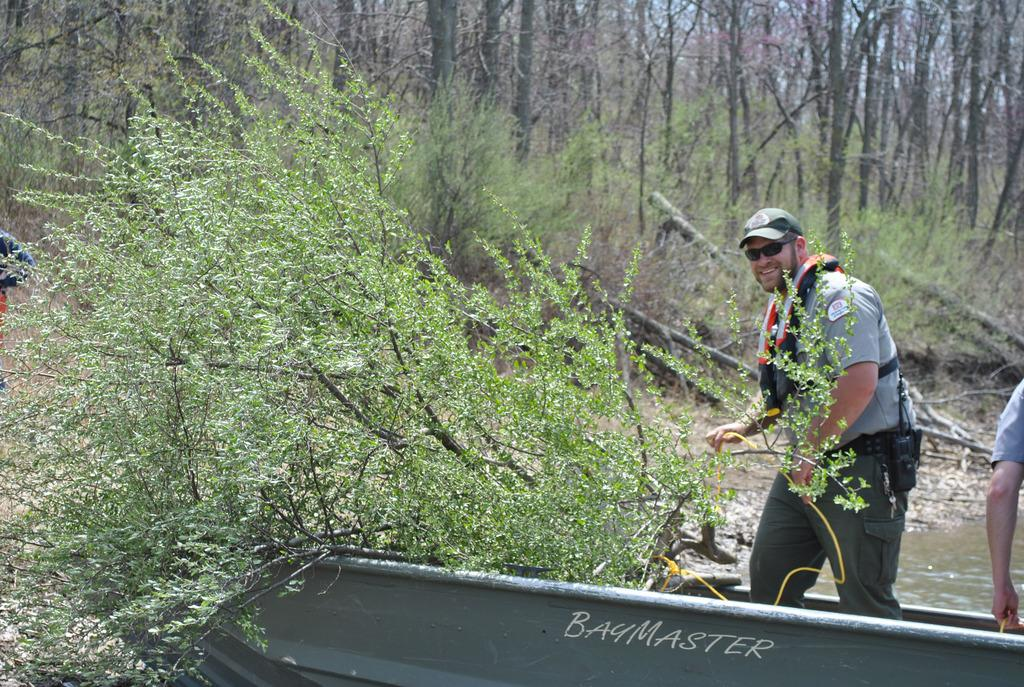<image>
Share a concise interpretation of the image provided. A man is standing in a boat saying BayMaster that is near the shore. 